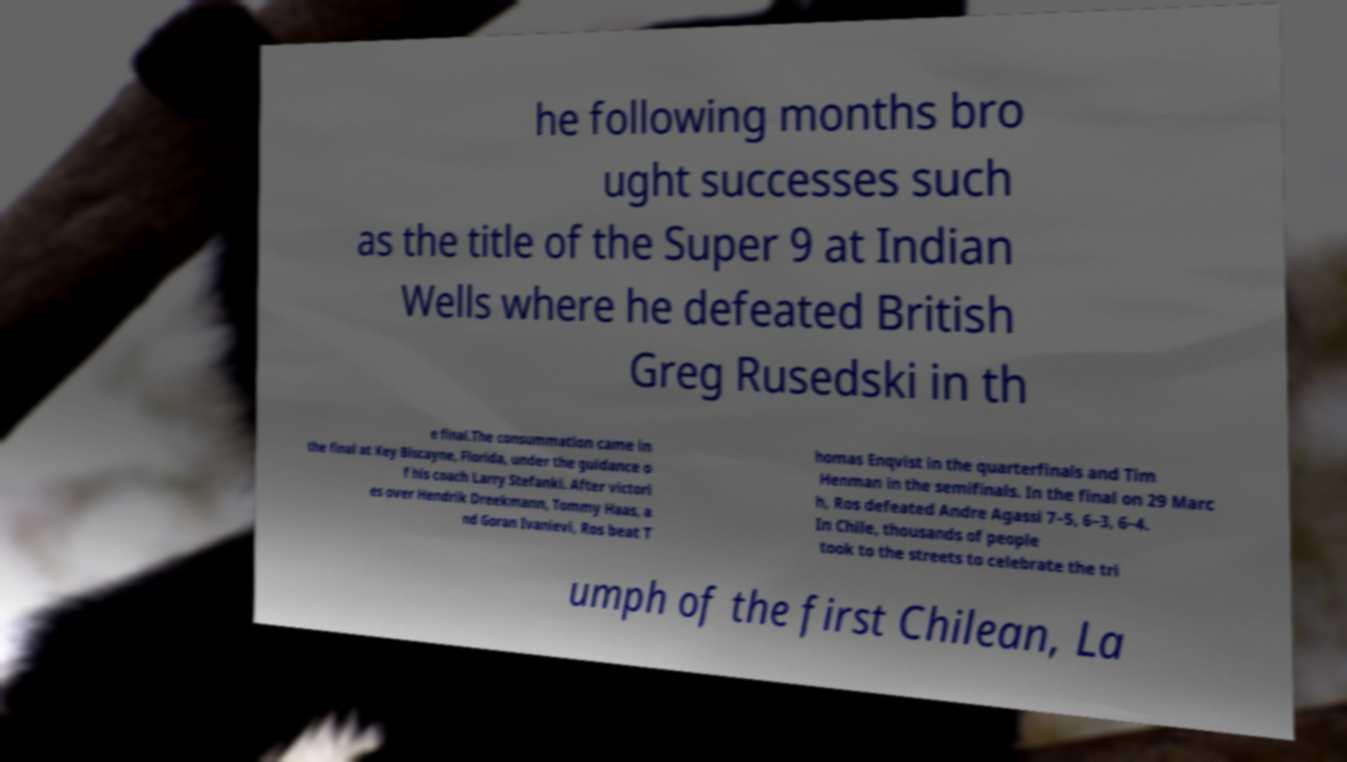Can you read and provide the text displayed in the image?This photo seems to have some interesting text. Can you extract and type it out for me? he following months bro ught successes such as the title of the Super 9 at Indian Wells where he defeated British Greg Rusedski in th e final.The consummation came in the final at Key Biscayne, Florida, under the guidance o f his coach Larry Stefanki. After victori es over Hendrik Dreekmann, Tommy Haas, a nd Goran Ivanievi, Ros beat T homas Enqvist in the quarterfinals and Tim Henman in the semifinals. In the final on 29 Marc h, Ros defeated Andre Agassi 7–5, 6–3, 6–4. In Chile, thousands of people took to the streets to celebrate the tri umph of the first Chilean, La 